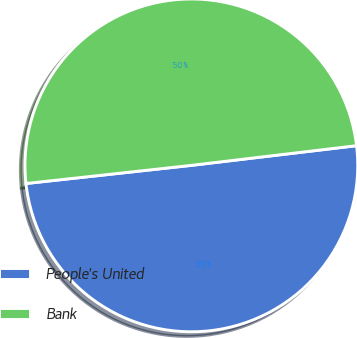Convert chart. <chart><loc_0><loc_0><loc_500><loc_500><pie_chart><fcel>People's United<fcel>Bank<nl><fcel>50.15%<fcel>49.85%<nl></chart> 